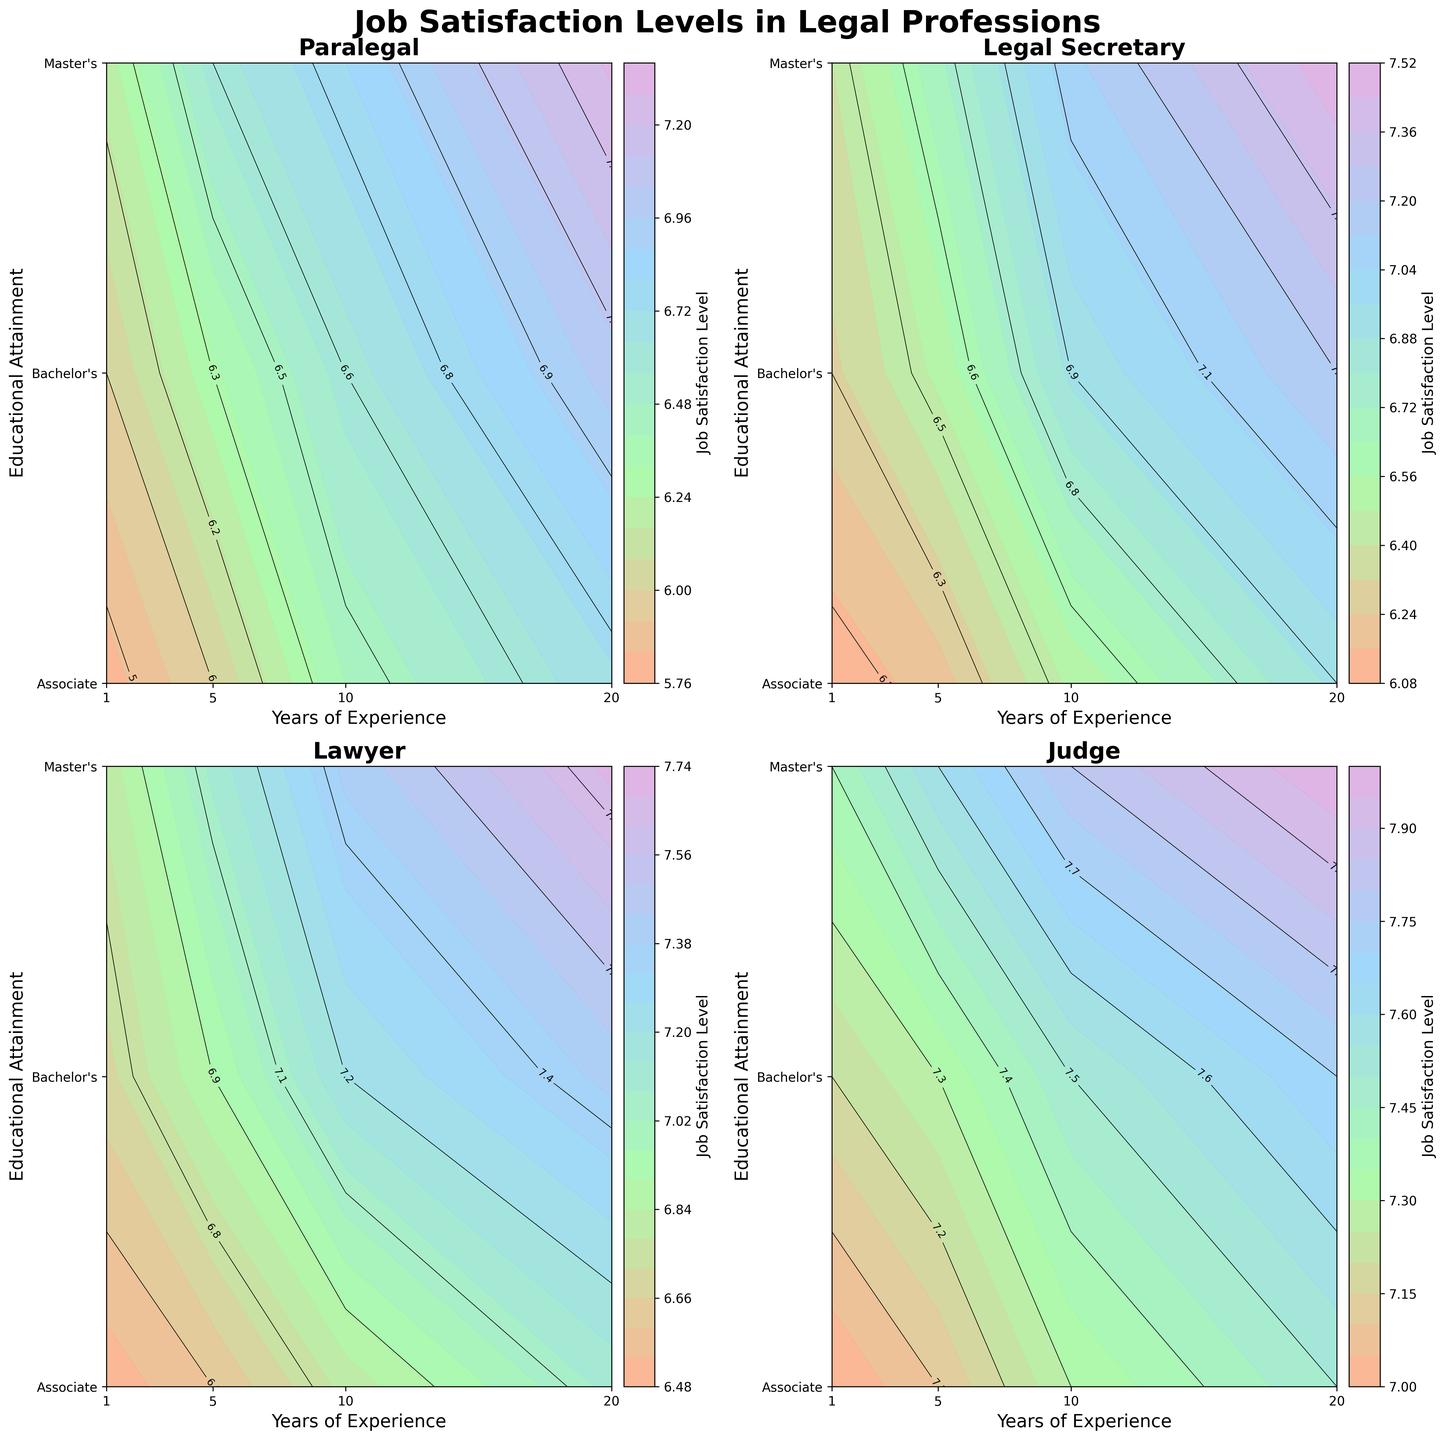What is the overall title of the plot? The overall title of the plot is usually displayed at the top of the figure, often more prominent than other text elements within the plot. In this case, it is centrally located at the top.
Answer: Job Satisfaction Levels in Legal Professions What are the professions evaluated in the plot? The professions evaluated are typically labeled on each individual subplot within the figure, often as the subplot titles. Here, there are four subplots each displaying a different profession.
Answer: Paralegal, Legal Secretary, Lawyer, Judge What is used to represent different educational attainments on the y-axis? Educational attainments are generally labeled along the y-axis of each subplot. In this case, educational levels are represented numerically and then labeled.
Answer: Associate, Bachelor's, Master's How does job satisfaction change for legal secretaries as their years of experience increase, holding educational attainment constant? By looking at each of the contour plots for legal secretaries, one can trace the lines or color shifts from left to right to observe how values change. In each subplot, as the years of experience increase, satisfaction levels also increase.
Answer: It increases Which profession shows the highest job satisfaction for individuals with a master's degree and 20 years of experience? One needs to locate the contours corresponding to 20 years of experience and a master's degree for each profession. The highest value among these will indicate which profession has the highest satisfaction.
Answer: Judge For paralegals, how much does job satisfaction change from having an associate degree to a master's degree for those with 1 year of experience? By examining the contour plot data point at 1 year of experience, compare the satisfaction values at the y-values corresponding to Associate and Master's degrees. Subtract the Associate value from the Master's value.
Answer: 0.4 (6.2 - 5.8) Which profession sees the least increase in job satisfaction with increased educational attainment across all years of experience? For all professions, observe the contour shifts vertically (educational attainment). Determine which profession exhibits the smallest vertical change overall.
Answer: Legal Secretary For lawyers, between what years of experience is the job satisfaction level around 7.0 if the individual has a bachelor's degree? Locate the contour plots that represent a job satisfaction level of 7.0 and cross-reference with the bachelor's degree line. Identify the respective years of experience that lie along this contour line.
Answer: 10 to 20 years Are there any professions where job satisfaction exceeds 8.0 for the highest educational attainment and experience levels? Examine the highest educational and experience points (Master's degree and 20 years) on each contour plot. Check for any values that exceed 8.0.
Answer: Yes, Judge Which educational attainment level provides the highest job satisfaction for paralegals with 10 years of experience? Look at the contour representing 10 years of experience for Paralegal. Identify which y-value (educational level) has the highest corresponding satisfaction level.
Answer: Master's Degree 